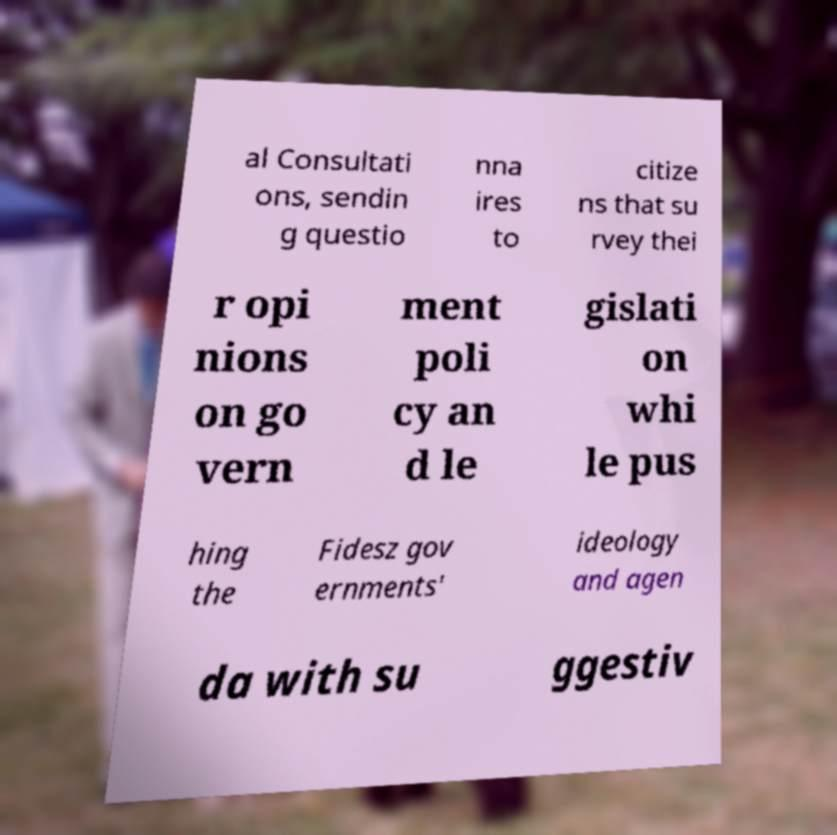What messages or text are displayed in this image? I need them in a readable, typed format. al Consultati ons, sendin g questio nna ires to citize ns that su rvey thei r opi nions on go vern ment poli cy an d le gislati on whi le pus hing the Fidesz gov ernments' ideology and agen da with su ggestiv 